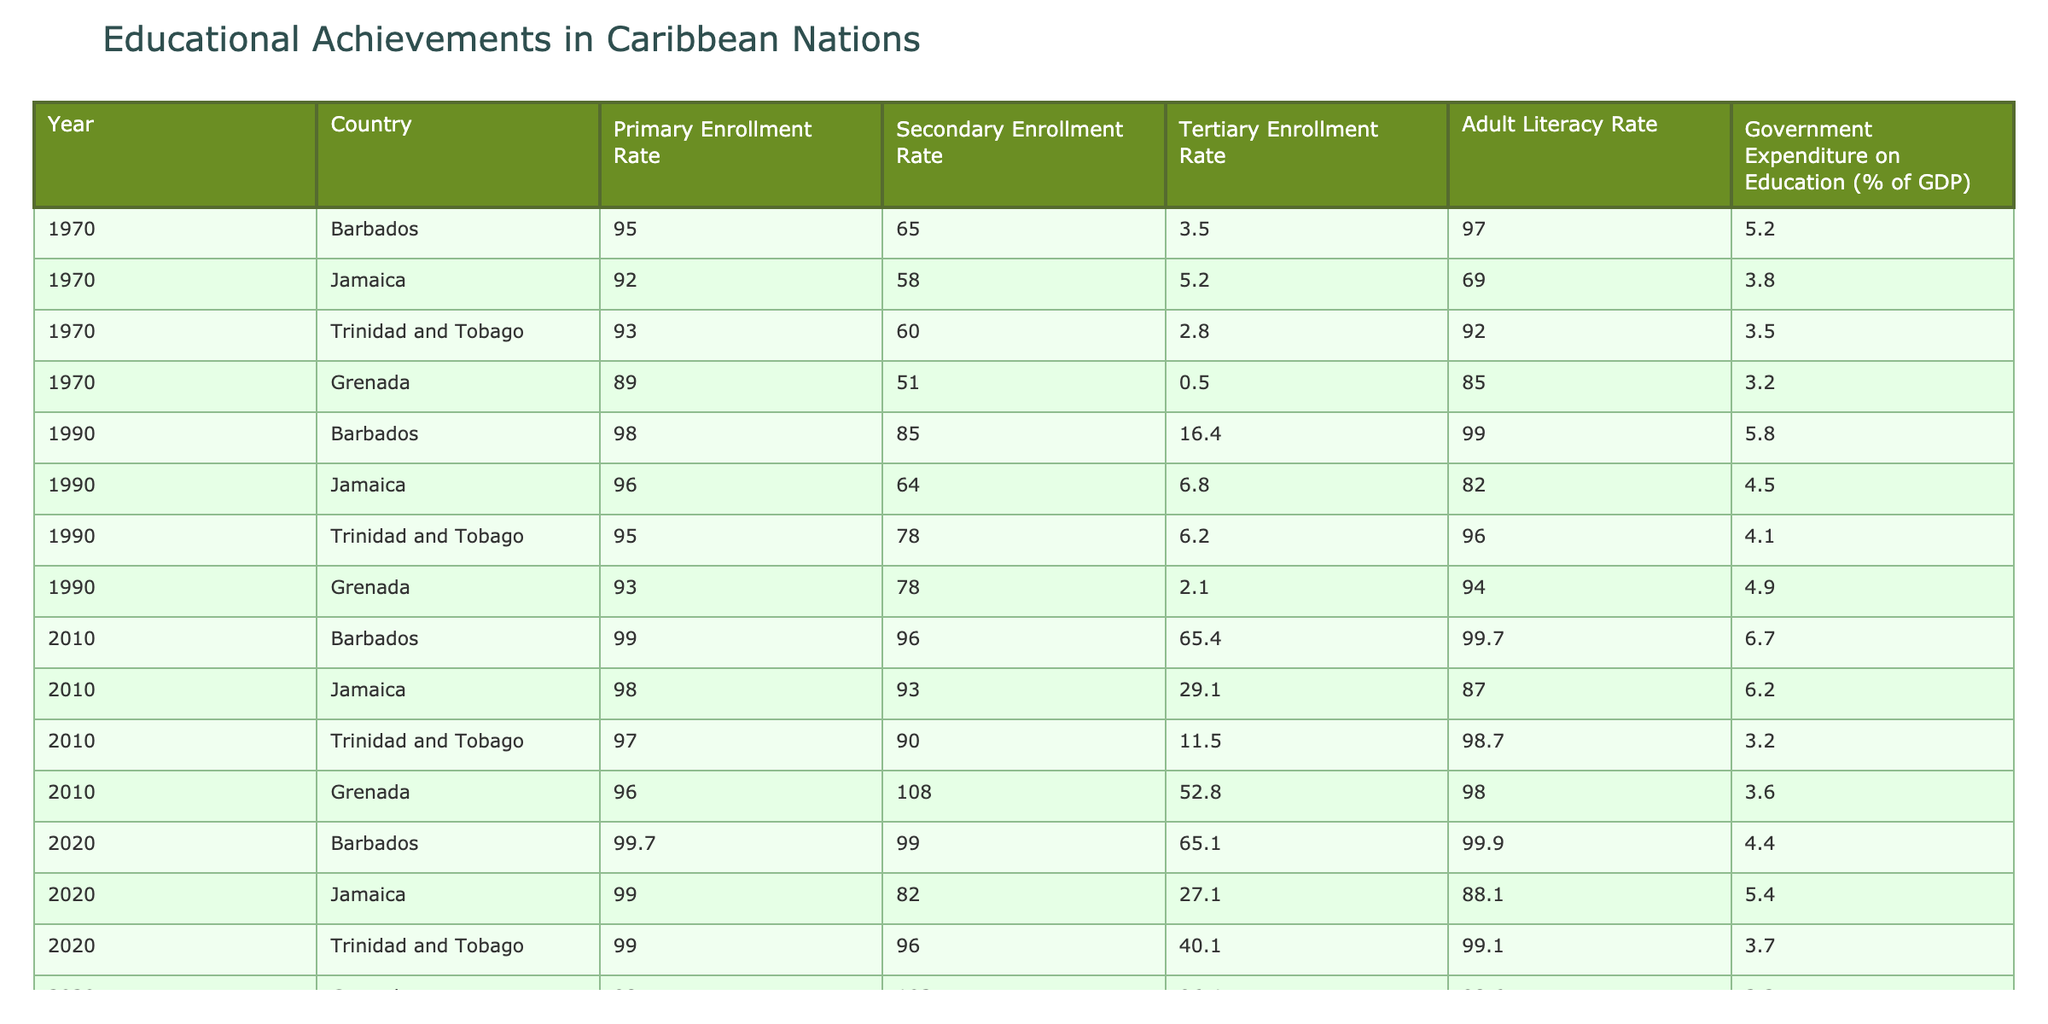What was Barbados's primary enrollment rate in 1990? In 1990, the primary enrollment rate for Barbados is listed in the table as 98.
Answer: 98 Which country had the highest secondary enrollment rate in 2010? Looking at the secondary enrollment rates in 2010, Grenada shows a rate of 108, which is higher than the other countries listed for that year.
Answer: Grenada What is the average tertiary enrollment rate across all countries in 2020? To find the average tertiary enrollment rate for 2020, we sum the rates: (65.1 + 27.1 + 40.1 + 96.4) = 228.7. There are 4 countries, so we divide by 4, giving us 228.7 / 4 = 57.175.
Answer: 57.175 Did Trinidad and Tobago have a lower adult literacy rate than Jamaica in 1970? In 1970, Trinidad and Tobago had an adult literacy rate of 92, while Jamaica had a literacy rate of 69. Since 92 is greater than 69, Trinidad and Tobago did not have a lower rate.
Answer: No How much did government expenditure on education change for Barbados from 1970 to 2010? In 1970, Barbados had a government expenditure on education of 5.2% of GDP, which increased to 6.7% by 2010. The change is calculated as 6.7 - 5.2 = 1.5%.
Answer: 1.5% 